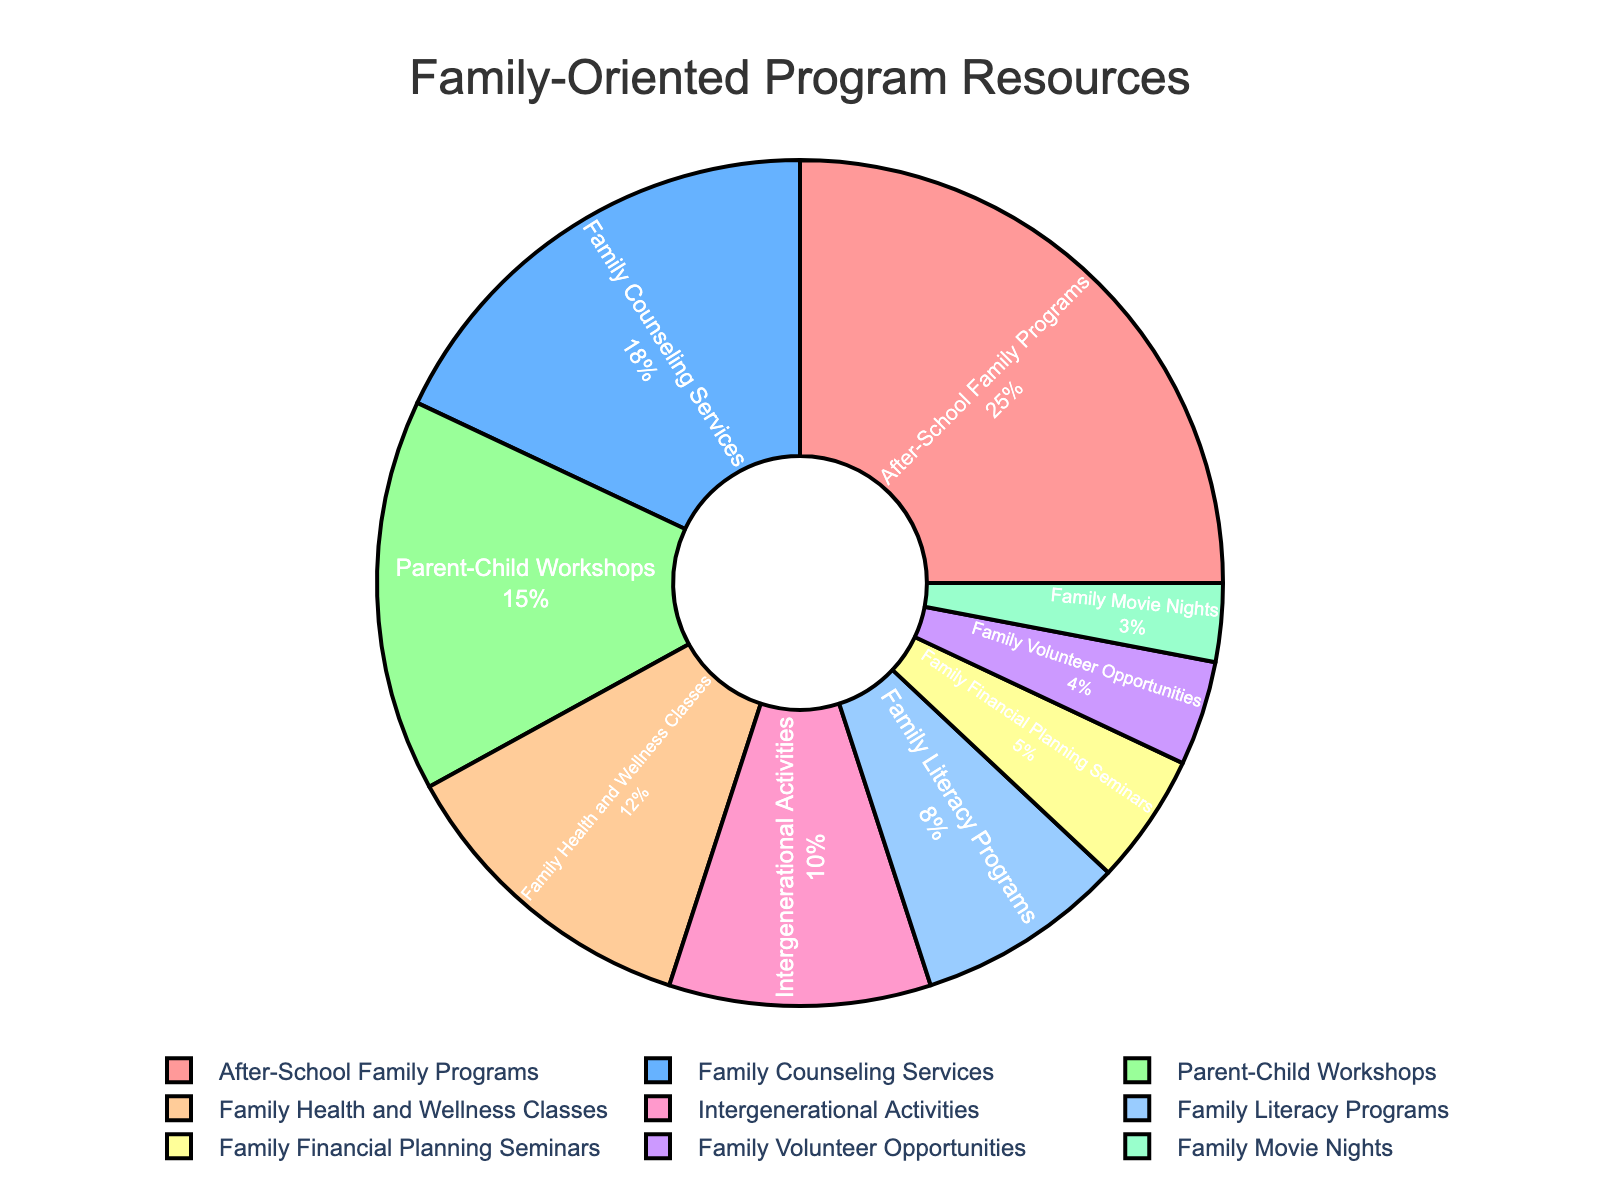What percentage is allocated to the After-School Family Programs? To determine the percentage allocated to After-School Family Programs, we need to look at the segment labeled 'After-School Family Programs' in the pie chart. The provided data indicates that this segment represents 25%.
Answer: 25% Which program receives the least allocation? The program with the smallest segment in the pie chart represents the lowest allocation. The provided data indicates that 'Family Movie Nights' receive the smallest allocation of 3%.
Answer: Family Movie Nights How much more percentage does Family Counseling Services receive than Family Literacy Programs? To find the difference between the allocations of Family Counseling Services and Family Literacy Programs, subtract the percentage for Family Literacy Programs from that of Family Counseling Services: 18% - 8% = 10%.
Answer: 10% What is the combined percentage of Parent-Child Workshops and Family Financial Planning Seminars? To find the combined percentage, sum up the allocations for Parent-Child Workshops and Family Financial Planning Seminars: 15% + 5% = 20%.
Answer: 20% Which program is allocated an amount exactly between the highest and the lowest? To find the program allocated an amount exactly between the highest (After-School Family Programs, 25%) and the lowest (Family Movie Nights, 3%), we need to consider the midpoint percentage, which is (25% + 3%) / 2 = 14%. The program that most closely matches this midpoint is 'Parent-Child Workshops' at 15%.
Answer: Parent-Child Workshops What is the total percentage allocated to family-oriented programs related to health, wellness, and counseling? To find the total percentage, sum up the allocations for Family Counseling Services and Family Health and Wellness Classes: 18% + 12% = 30%.
Answer: 30% Which program has a percentage half of that allocated to After-School Family Programs? To find the program with a percentage half of After-School Family Programs' allocation (25%), we calculate 25% / 2 = 12.5%. The closest program percentage is 'Family Health and Wellness Classes' at 12%.
Answer: Family Health and Wellness Classes 